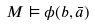Convert formula to latex. <formula><loc_0><loc_0><loc_500><loc_500>M \vDash \phi ( b , { \bar { a } } )</formula> 